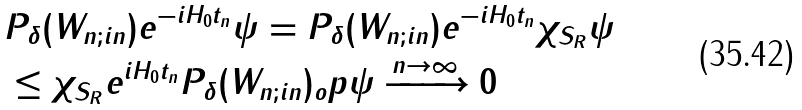Convert formula to latex. <formula><loc_0><loc_0><loc_500><loc_500>& \| P _ { \delta } ( W _ { n ; i n } ) e ^ { - i H _ { 0 } t _ { n } } \psi \| = \| P _ { \delta } ( W _ { n ; i n } ) e ^ { - i H _ { 0 } t _ { n } } \chi _ { S _ { R } } \psi \| \\ & \leq \| \chi _ { S _ { R } } e ^ { i H _ { 0 } t _ { n } } P _ { \delta } ( W _ { n ; i n } ) \| _ { o } p \| \psi \| \xrightarrow { n \rightarrow \infty } 0</formula> 